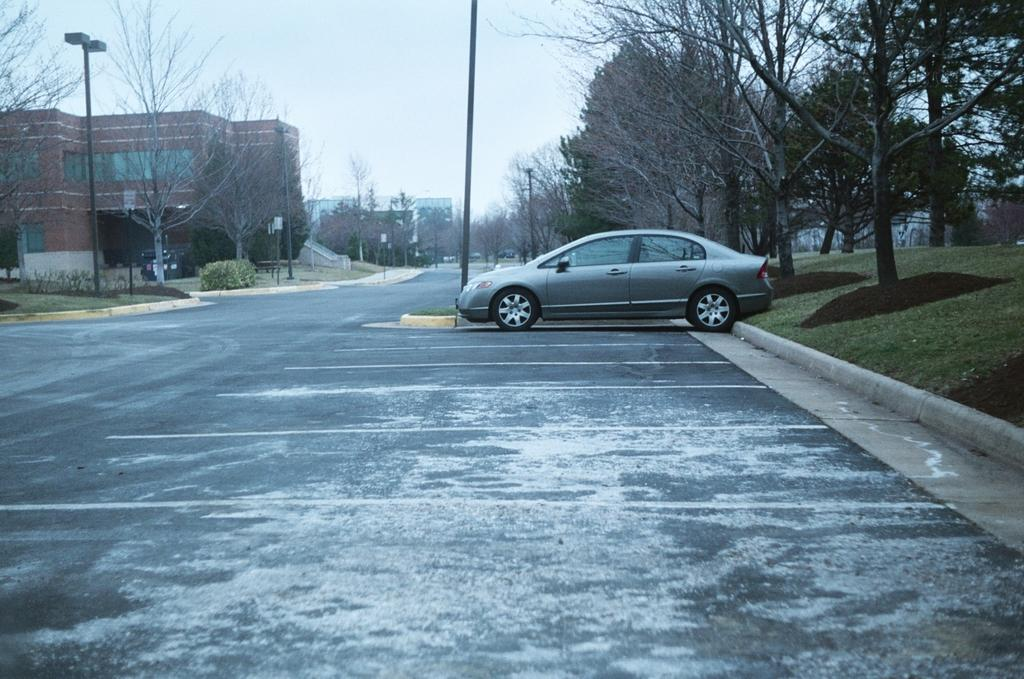What is parked in the image? There is a car parked in the image. Where is the car located? The car is in a parking lot. What can be seen in the background of the image? There is a group of trees, poles, a building, and the sky visible in the background of the image. Can you see your friend taking a picture of the car with a camera in the image? There is no friend or camera present in the image. 